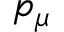Convert formula to latex. <formula><loc_0><loc_0><loc_500><loc_500>p _ { \mu }</formula> 